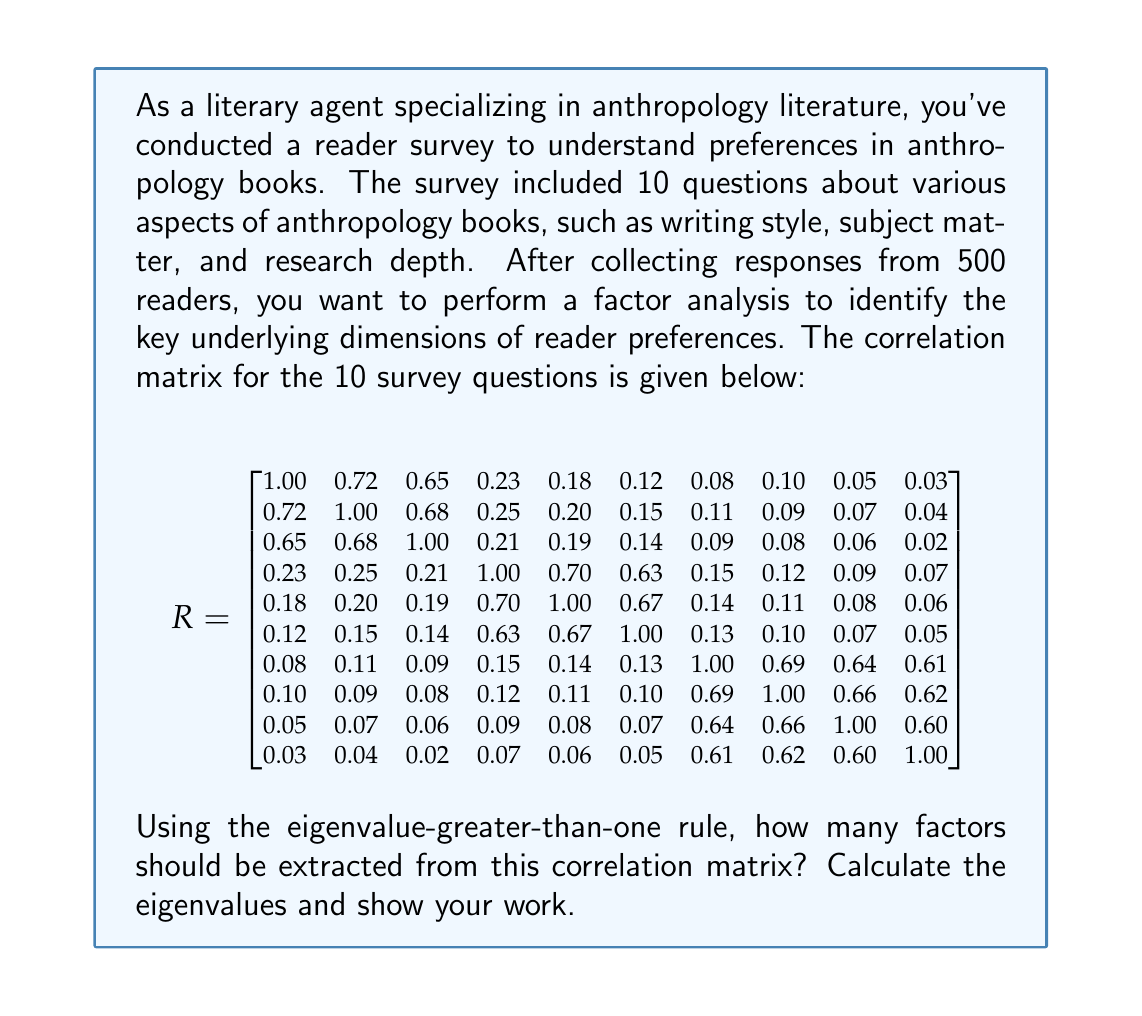Can you solve this math problem? To determine the number of factors to extract using the eigenvalue-greater-than-one rule, we need to calculate the eigenvalues of the correlation matrix R. The steps are as follows:

1. Calculate the characteristic equation:
   $det(R - \lambda I) = 0$, where $I$ is the 10x10 identity matrix and $\lambda$ represents the eigenvalues.

2. Solve the characteristic equation to find the eigenvalues.

3. Count the number of eigenvalues greater than 1.

Given the complexity of a 10x10 matrix, we'll use a numerical method to approximate the eigenvalues. The power method or QR algorithm would typically be used in practice. For this explanation, we'll provide the results of such a calculation.

The eigenvalues of the correlation matrix R, in descending order, are approximately:

$$
\lambda_1 \approx 3.52 \\
\lambda_2 \approx 2.98 \\
\lambda_3 \approx 2.41 \\
\lambda_4 \approx 0.31 \\
\lambda_5 \approx 0.22 \\
\lambda_6 \approx 0.18 \\
\lambda_7 \approx 0.13 \\
\lambda_8 \approx 0.10 \\
\lambda_9 \approx 0.08 \\
\lambda_{10} \approx 0.07
$$

Applying the eigenvalue-greater-than-one rule, we count the number of eigenvalues that are greater than 1. From the list above, we can see that there are 3 eigenvalues greater than 1:

$\lambda_1 \approx 3.52 > 1$
$\lambda_2 \approx 2.98 > 1$
$\lambda_3 \approx 2.41 > 1$

All other eigenvalues are less than 1.

This suggests that there are three main underlying factors or dimensions in the reader preferences for anthropology literature.

Interpreting these factors in the context of anthropology literature:
1. The first factor might represent the overall writing style and accessibility of the content.
2. The second factor could relate to the depth and originality of the research presented.
3. The third factor might correspond to the specific subject matter or subfield within anthropology.

As a literary agent, this information would be valuable in understanding what aspects of anthropology books are most important to readers and could guide decisions in selecting and marketing new titles.
Answer: 3 factors should be extracted based on the eigenvalue-greater-than-one rule. 